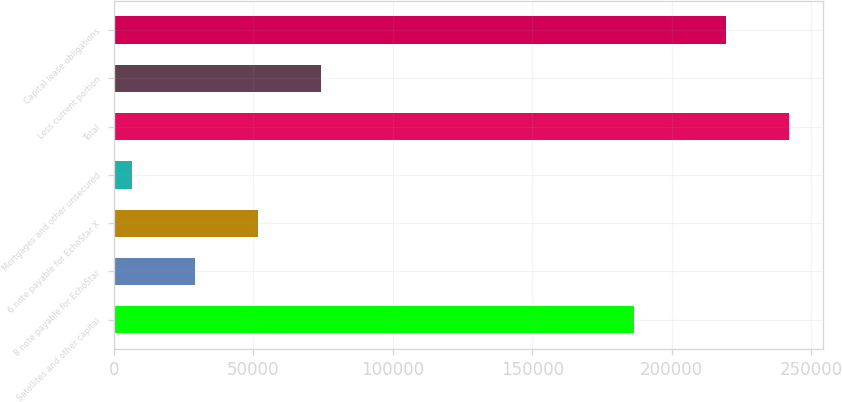Convert chart to OTSL. <chart><loc_0><loc_0><loc_500><loc_500><bar_chart><fcel>Satellites and other capital<fcel>8 note payable for EchoStar<fcel>6 note payable for EchoStar X<fcel>Mortgages and other unsecured<fcel>Total<fcel>Less current portion<fcel>Capital lease obligations<nl><fcel>186545<fcel>28974.4<fcel>51616.8<fcel>6332<fcel>242065<fcel>74259.2<fcel>219423<nl></chart> 